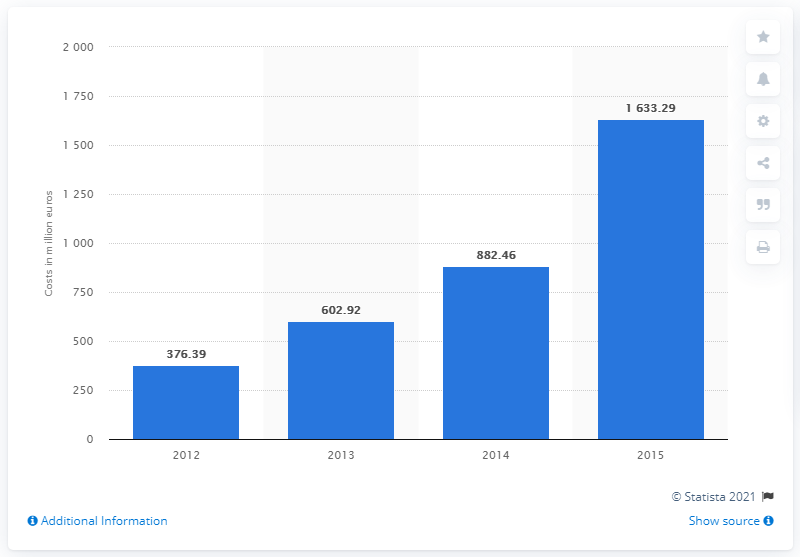Specify some key components in this picture. In 2015, Spotify paid $1633.29 in royalty fees. 